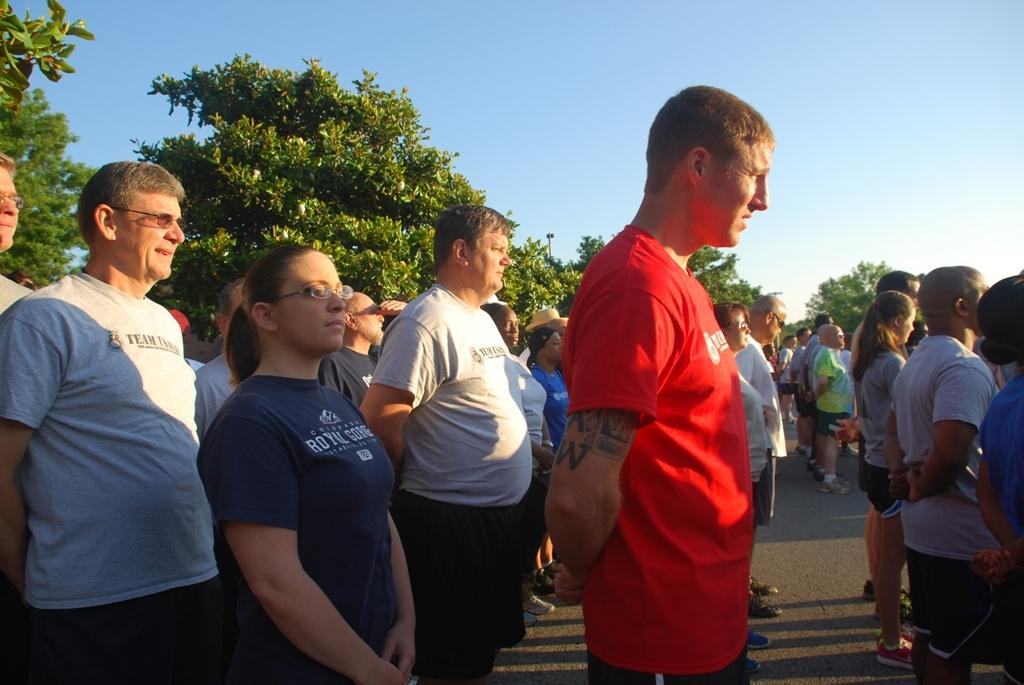What can be seen in the foreground of the image? There are persons standing on the road in the foreground of the image. What is visible in the background of the image? There are trees and the sky in the background of the image. What type of straw is being used by the persons in the image? There is no straw present in the image; it features persons standing on the road with trees and the sky visible in the background. What is the reaction of the trees to the persons standing on the road? The trees do not have a reaction, as they are inanimate objects and cannot react to the persons standing on the road. 